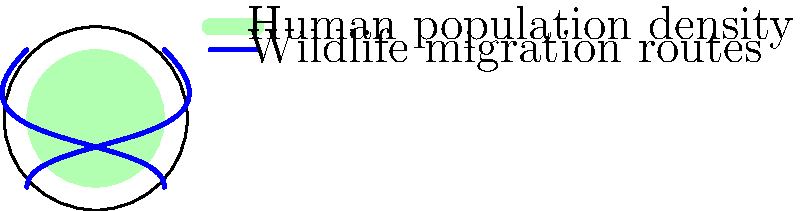Based on the map overlay showing human population density and wildlife migration routes, what relationship can be inferred between these two factors? How might this information be used in an economic model to assess the socio-economic impacts of human activities on wildlife migration? To answer this question, let's analyze the map overlay step-by-step:

1. Human population density:
   - The green shaded area represents human population density.
   - It covers a significant portion of the circular map, indicating a widespread human presence.

2. Wildlife migration routes:
   - The blue lines represent wildlife migration routes.
   - There are two main routes crossing the map diagonally.

3. Relationship between human population density and wildlife migration:
   - The migration routes intersect with areas of human population density.
   - This suggests a potential conflict between human settlements and wildlife movement.

4. Implications for economic modeling:
   - The overlap between human-populated areas and migration routes indicates a need for land-use management and conservation efforts.
   - Economic models could be used to:
     a) Quantify the costs of habitat fragmentation and loss of biodiversity.
     b) Estimate the economic value of preserving wildlife corridors.
     c) Analyze the trade-offs between urban development and conservation.
     d) Assess the potential for eco-tourism related to wildlife migration.

5. Socio-economic impacts:
   - The model could help predict:
     a) Changes in local economies due to altered wildlife patterns.
     b) Costs of human-wildlife conflicts.
     c) Potential benefits of wildlife-friendly urban planning.

6. Policy implications:
   - The economic model could inform decisions on:
     a) Land-use zoning to protect migration routes.
     b) Infrastructure development that minimizes disruption to wildlife.
     c) Incentives for conservation-friendly practices in high-density areas.

By incorporating this spatial relationship into economic models, policymakers can better understand and mitigate the socio-economic impacts of human activities on wildlife migration.
Answer: Inverse relationship between human density and wildlife migration; economic models can quantify costs/benefits of conservation vs. development, informing land-use policies. 